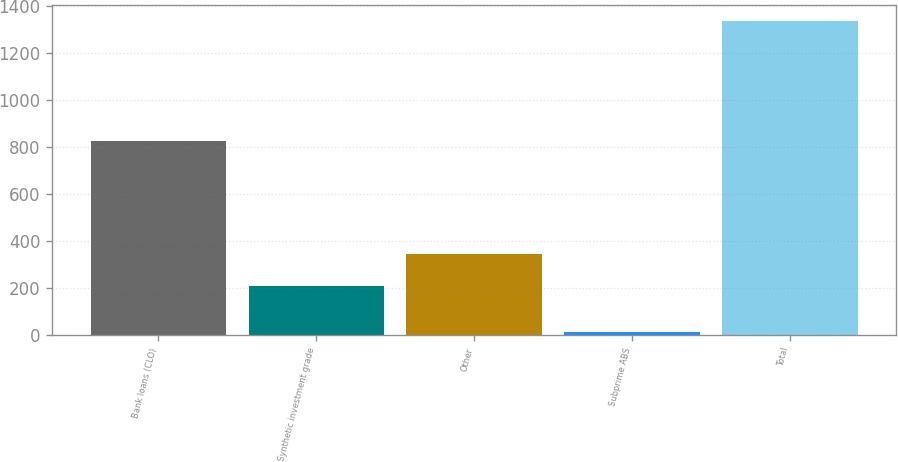Convert chart to OTSL. <chart><loc_0><loc_0><loc_500><loc_500><bar_chart><fcel>Bank loans (CLO)<fcel>Synthetic investment grade<fcel>Other<fcel>Subprime ABS<fcel>Total<nl><fcel>824<fcel>210<fcel>342.5<fcel>12<fcel>1337<nl></chart> 